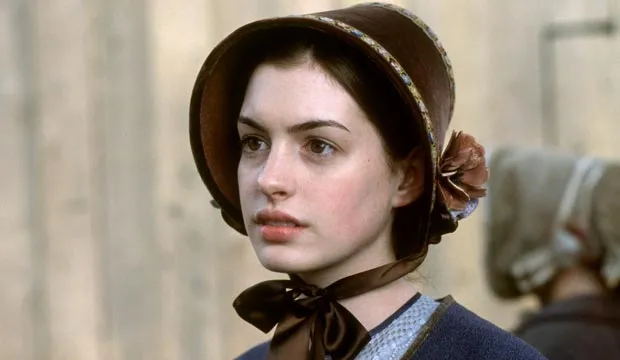What historical context could be inferred from this image? This image likely represents a scene set in the early 19th century, discernible from the style of the woman's dress and headwear. These fashion elements, such as the bonnet and the full-length dress, are indicative of women's clothing from that period, commonly seen in historical adaptations involving themes of societal roles, class distinction, or the personal struggles of the characters within those constraints. 